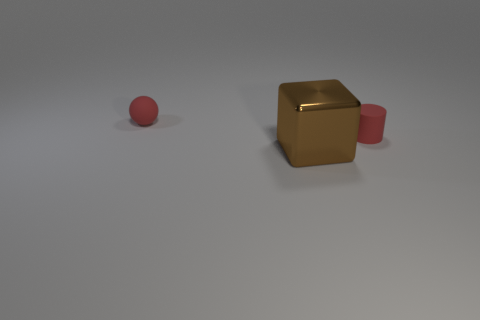Add 2 balls. How many objects exist? 5 Subtract all balls. How many objects are left? 2 Subtract all gray balls. Subtract all rubber things. How many objects are left? 1 Add 1 tiny cylinders. How many tiny cylinders are left? 2 Add 2 small things. How many small things exist? 4 Subtract 0 purple blocks. How many objects are left? 3 